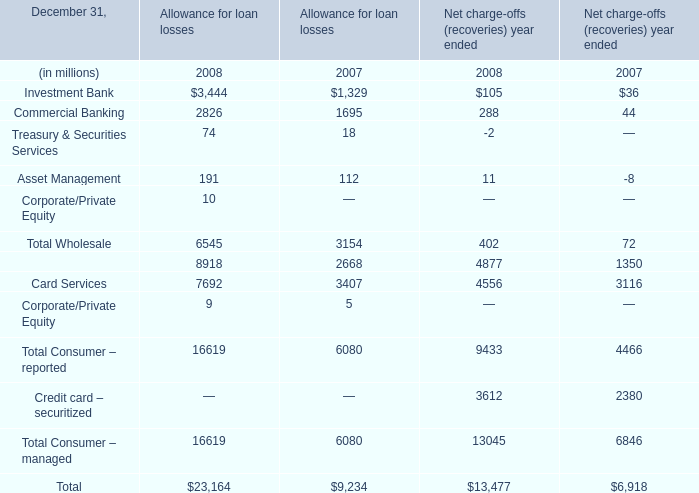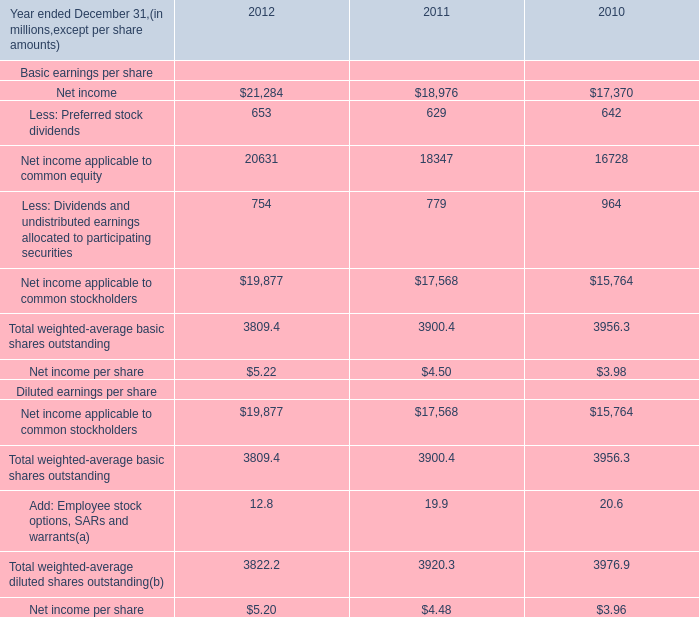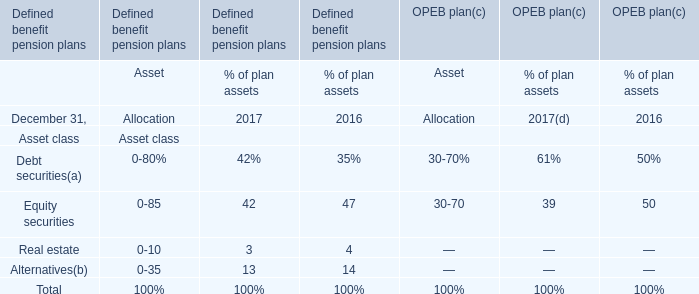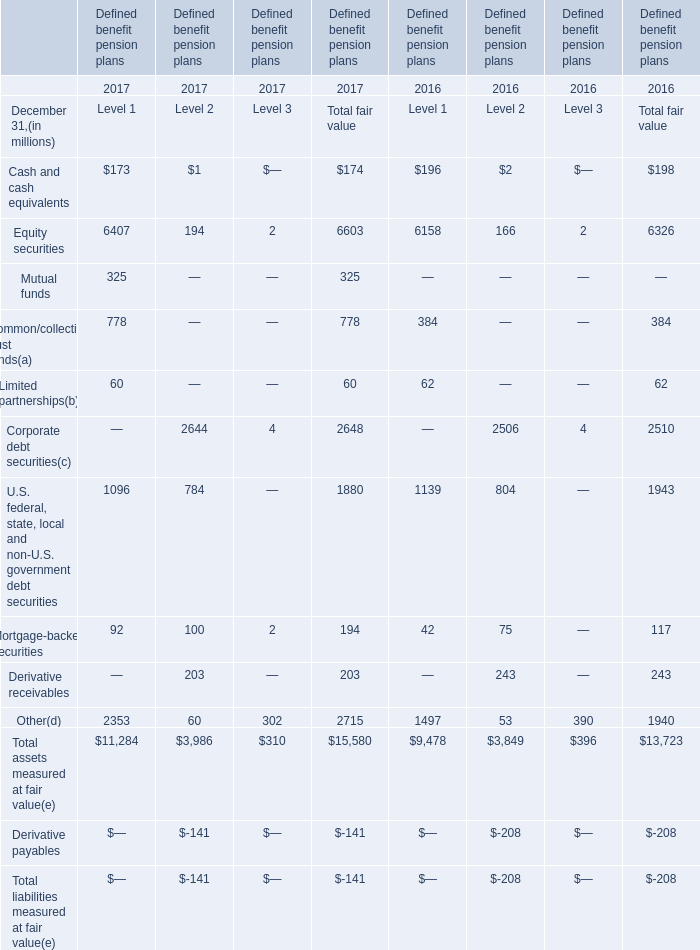What is the average value of Allowance for loan losses in 2007, for Commercial Banking, Asset Management, and Retail Financial Services ? (in million) 
Computations: (((1695 + 112) + 2668) / 3)
Answer: 1491.66667. 